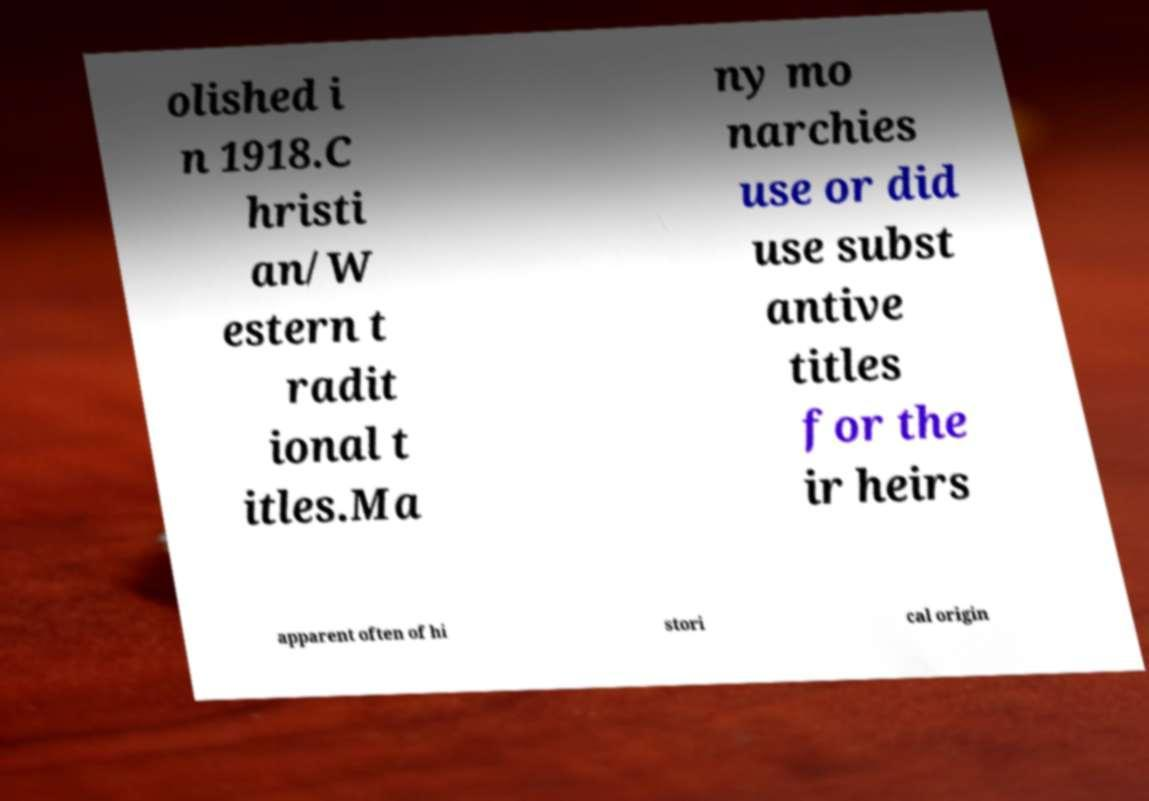I need the written content from this picture converted into text. Can you do that? olished i n 1918.C hristi an/W estern t radit ional t itles.Ma ny mo narchies use or did use subst antive titles for the ir heirs apparent often of hi stori cal origin 